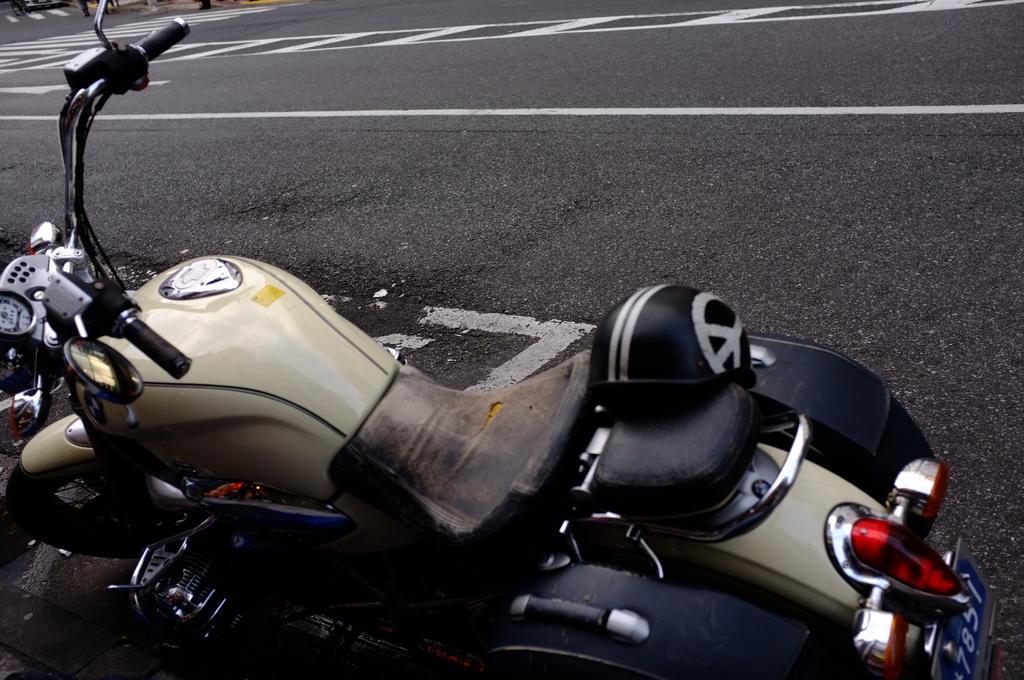Please provide a concise description of this image. In this image there is a bike in the bottom of this image and there is a road on the top of this image. 